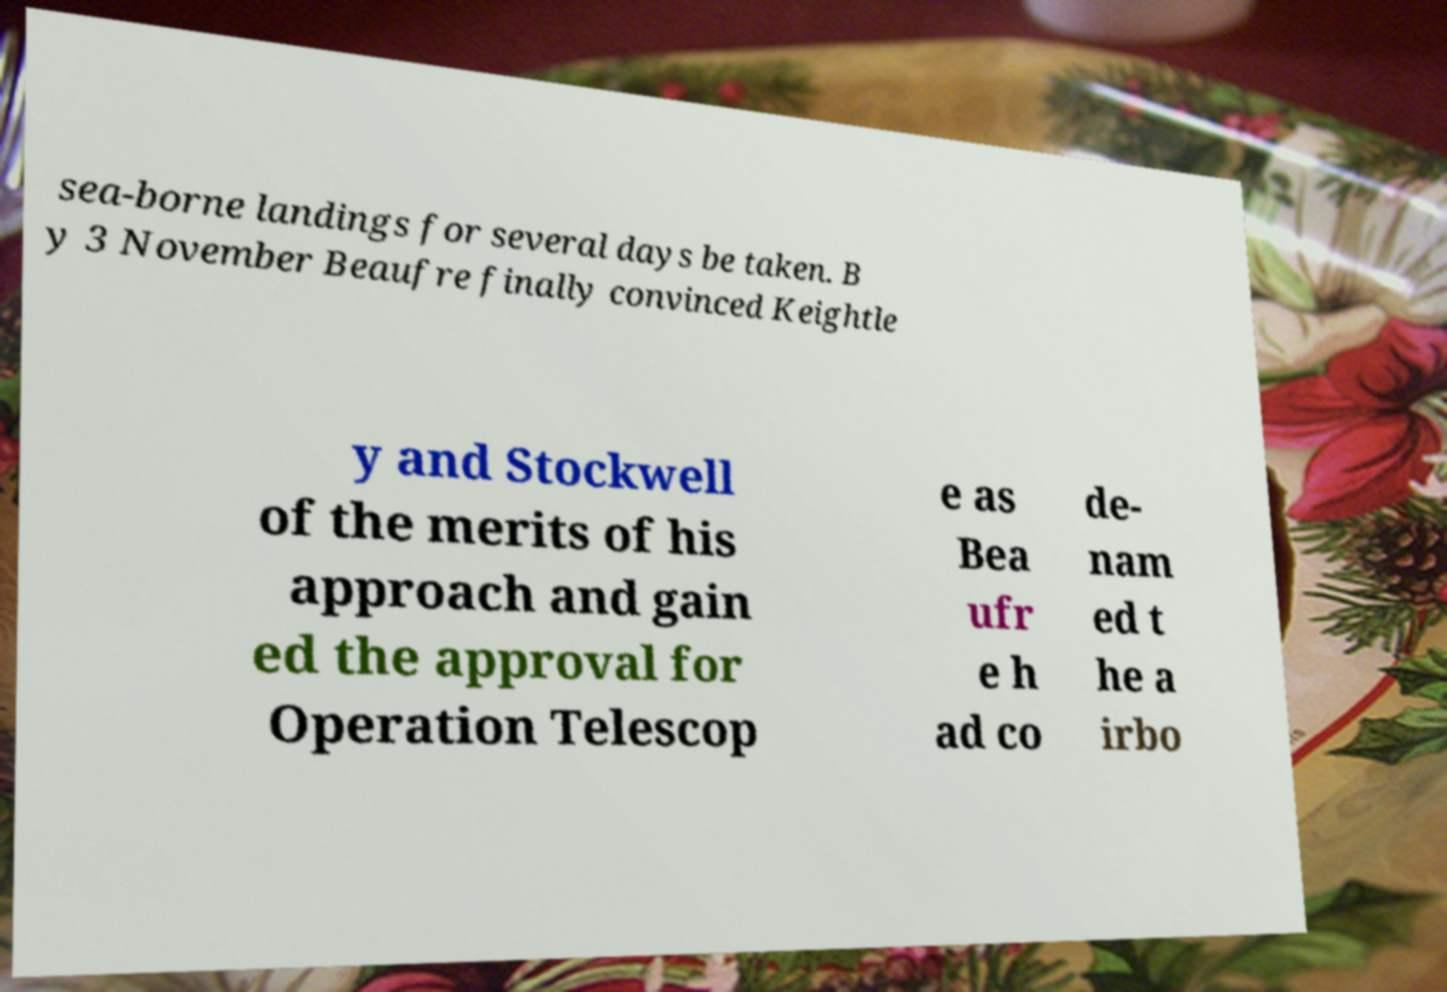Could you extract and type out the text from this image? sea-borne landings for several days be taken. B y 3 November Beaufre finally convinced Keightle y and Stockwell of the merits of his approach and gain ed the approval for Operation Telescop e as Bea ufr e h ad co de- nam ed t he a irbo 